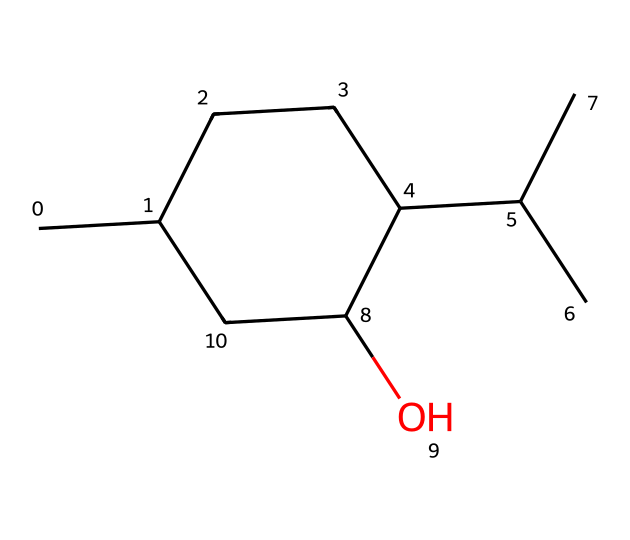what is the name of this chemical? The SMILES representation corresponds to menthol, a compound known for its minty aroma commonly used in air fresheners.
Answer: menthol how many carbon atoms are in this chemical structure? By counting the carbon atoms present in the cyclic structure, there are ten carbon atoms depicted in the SMILES string.
Answer: ten what type of structure does this chemical have? The chemical is a cycloalkane due to its cyclic structure consisting entirely of carbon and hydrogen atoms, making it a saturated hydrocarbon.
Answer: cycloalkane how many hydroxyl groups are present in this chemical structure? The SMILES representation shows one hydroxyl group (–OH) attached to one of the carbon atoms in the ring, indicating there is one hydroxyl group.
Answer: one is this chemical saturated or unsaturated? The structure has all single bonds and no double or triple bonds present in its cyclic formation, which confirms that it is saturated.
Answer: saturated which part of the chemical structure makes it suitable for air fresheners? The cyclic structure and specific functional group (the hydroxyl group) contribute to the pleasant aroma that is characteristic of menthol, making it effective for air fresheners.
Answer: cyclic structure and hydroxyl group what is the total number of hydrogen atoms in this chemical? The structure includes ten carbon atoms and one hydroxyl group, which results in a total of twenty-two hydrogen atoms when considering the valency of each carbon atom in a saturated cycloalkane.
Answer: twenty-two 